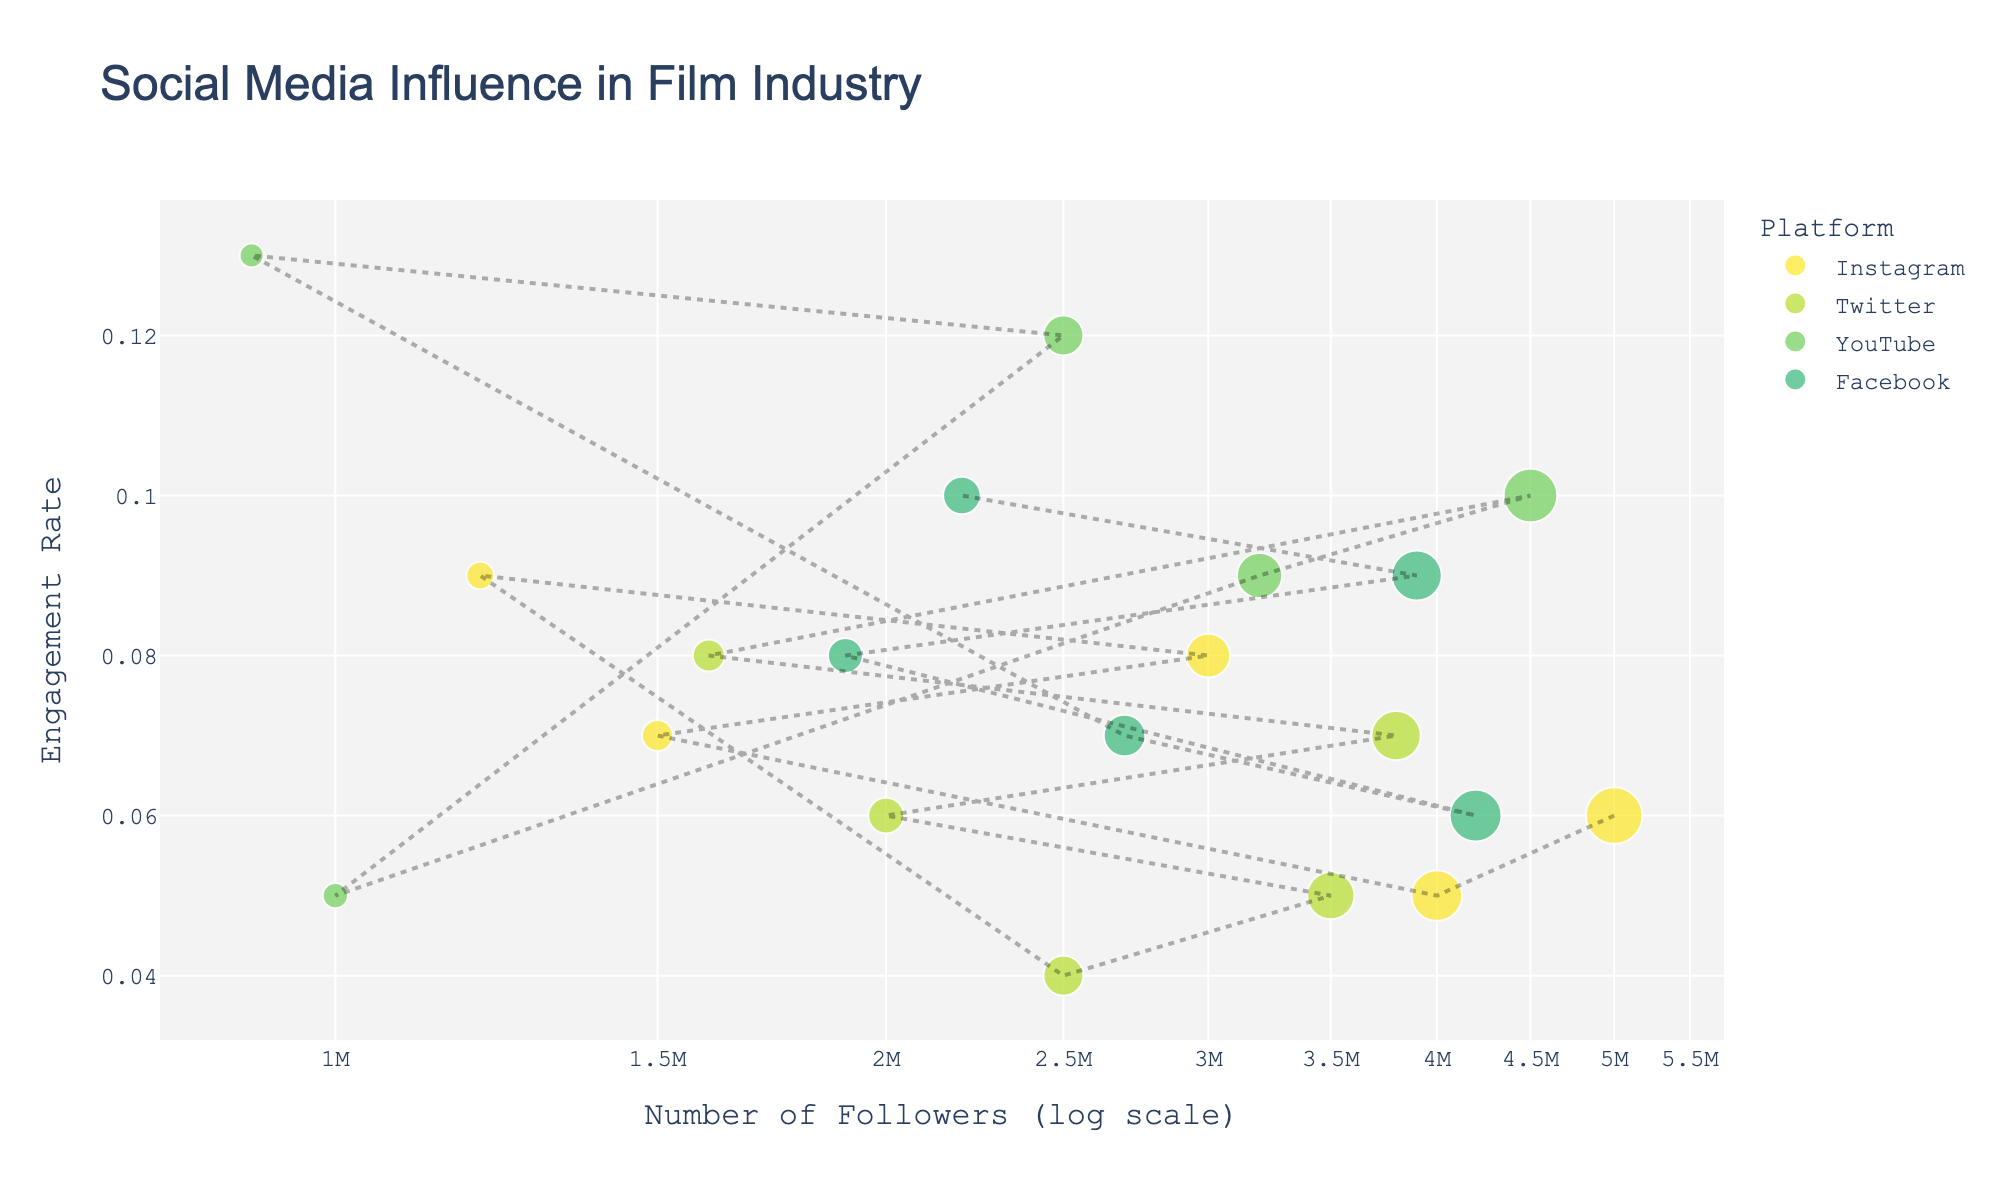What's the title of the plot? The title of the plot is usually displayed at the top of the figure. In this case, it is "Social Media Influence in Film Industry."
Answer: Social Media Influence in Film Industry How many platforms are represented in the scatter plot? To find the number of platforms, look at the legend on the plot. The legend usually lists the categories being represented by different colors.
Answer: 4 Which influencer on Instagram has the highest engagement rate? Look for the Instagram data points in the plot. Examine their y-axis positions to identify which one is the highest. This corresponds to the highest engagement rate.
Answer: Greta Gerwig What is the range of followers for influencers on YouTube? Look at the x-axis positions of the YouTube data points, which represent the followers. The minimum number of followers is at Sofia Coppola (1,000,000) and the maximum is at Quentin Tarantino (4,500,000).
Answer: 1,000,000 to 4,500,000 For Guillermo del Toro, which platform shows the highest engagement rate? Find the data points for Guillermo del Toro across all platforms and compare their y-axis positions. The highest y-axis position indicates the highest engagement rate.
Answer: YouTube What's the difference in engagement rate between Jordan Peele on Twitter and Facebook? Look at the data points for Jordan Peele on Twitter and Facebook. The y-axis values for Twitter and Facebook are 0.05 and 0.06 respectively. The difference is 0.06 - 0.05.
Answer: 0.01 Who has a higher engagement rate on Facebook, David Fincher or Ava DuVernay? Compare the y-axis positions of David Fincher and Ava DuVernay's data points on Facebook. The higher y-axis position indicates the higher engagement rate.
Answer: Ava DuVernay Which influencer has the largest number of followers and on which platform? Look for the data point that is farthest to the right on the x-axis since it represents the number of followers. Check the hover information or legend color to identify the platform.
Answer: Quentin Tarantino on Instagram Is there any influencer with an engagement rate of 0.1, and if so, on which platform? Check the y-axis positions for an engagement rate of 0.1. Identify the corresponding data points and their associated platforms through the legend or hover text.
Answer: Quentin Tarantino on YouTube and Kathryn Bigelow on Facebook 